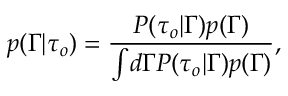<formula> <loc_0><loc_0><loc_500><loc_500>p ( \Gamma | \tau _ { o } ) = \frac { P ( \tau _ { o } | \Gamma ) p ( \Gamma ) } { \int \, d \Gamma P ( \tau _ { o } | \Gamma ) p ( \Gamma ) } ,</formula> 